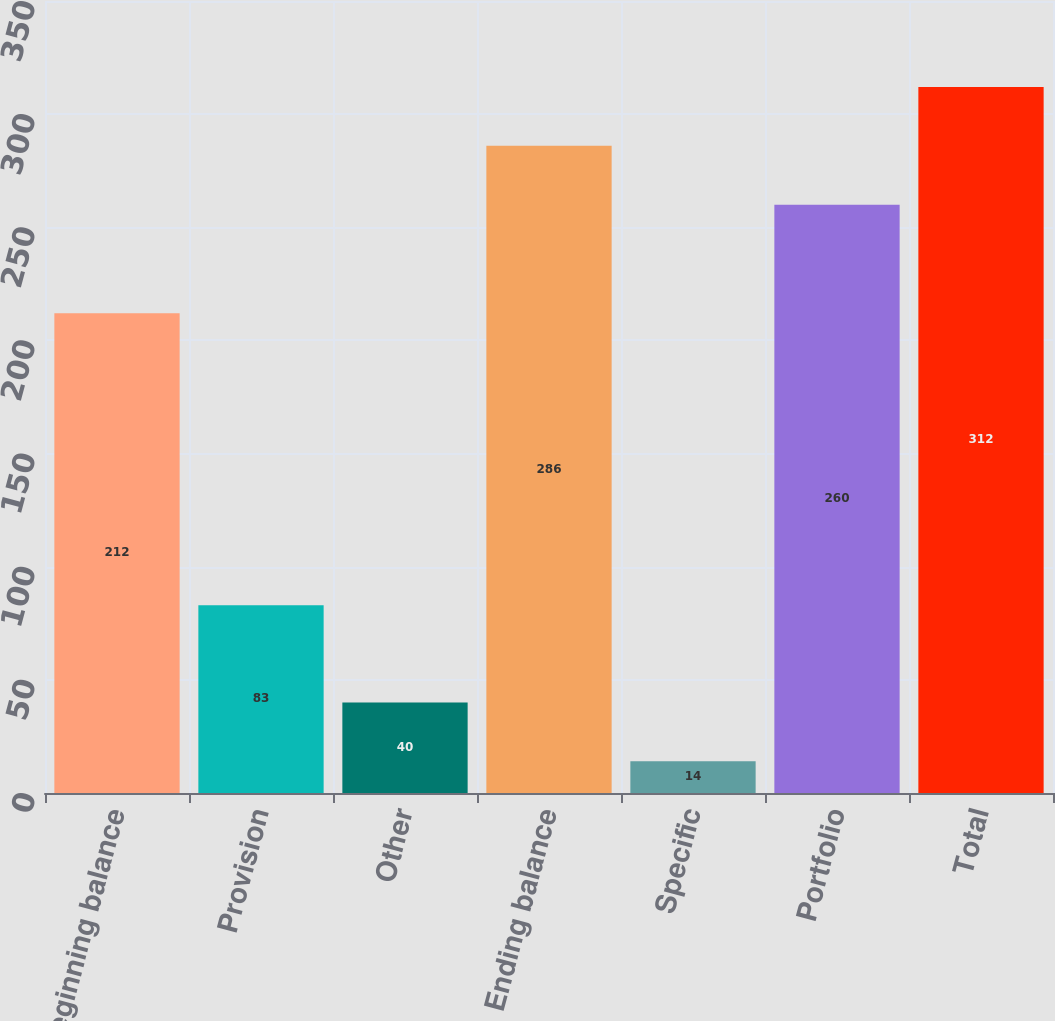<chart> <loc_0><loc_0><loc_500><loc_500><bar_chart><fcel>Beginning balance<fcel>Provision<fcel>Other<fcel>Ending balance<fcel>Specific<fcel>Portfolio<fcel>Total<nl><fcel>212<fcel>83<fcel>40<fcel>286<fcel>14<fcel>260<fcel>312<nl></chart> 